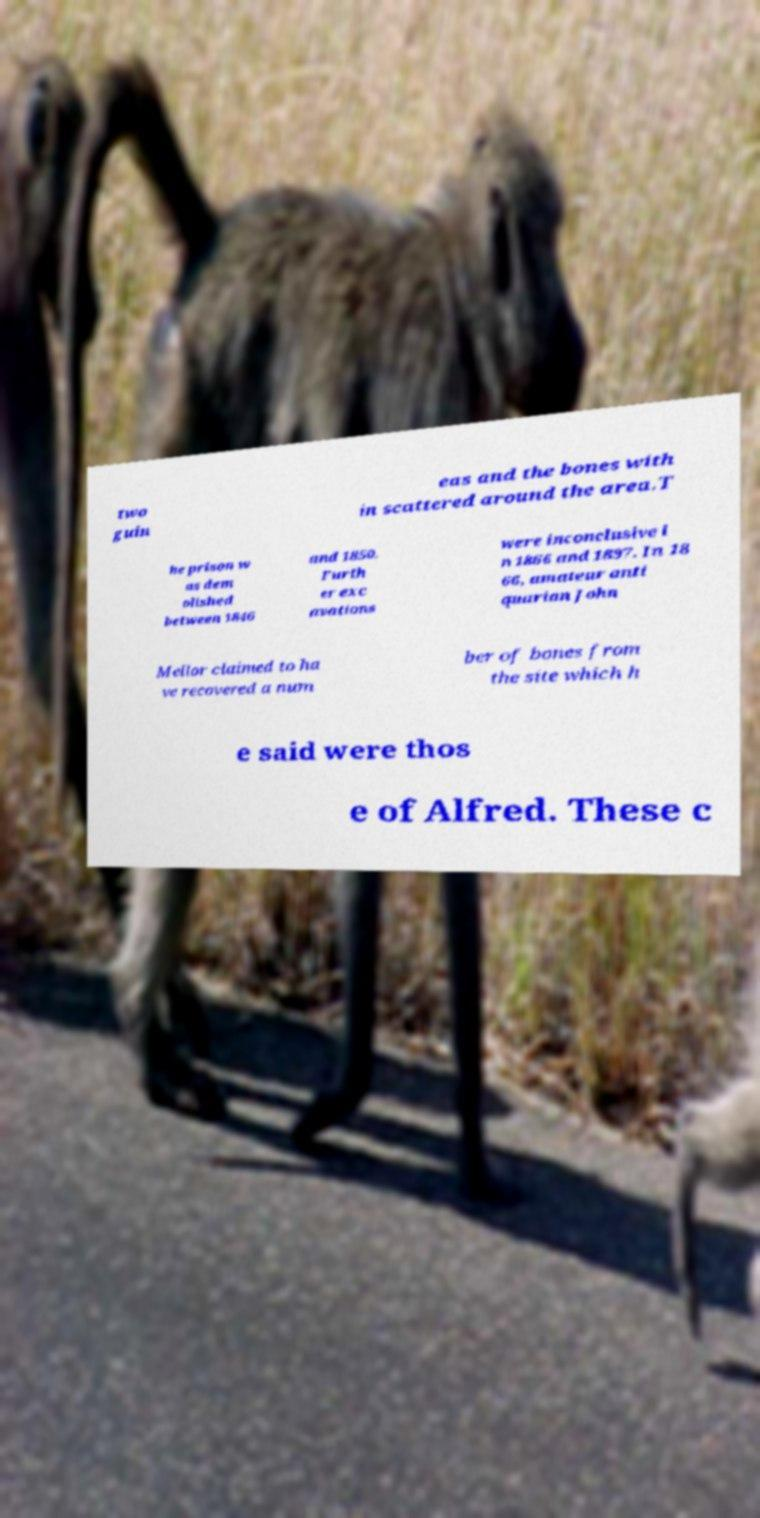Could you assist in decoding the text presented in this image and type it out clearly? two guin eas and the bones with in scattered around the area.T he prison w as dem olished between 1846 and 1850. Furth er exc avations were inconclusive i n 1866 and 1897. In 18 66, amateur anti quarian John Mellor claimed to ha ve recovered a num ber of bones from the site which h e said were thos e of Alfred. These c 